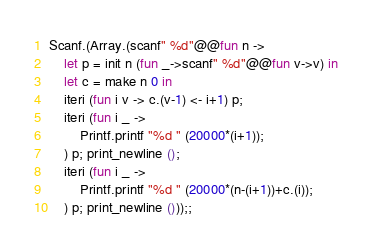Convert code to text. <code><loc_0><loc_0><loc_500><loc_500><_OCaml_>Scanf.(Array.(scanf" %d"@@fun n ->
	let p = init n (fun _->scanf" %d"@@fun v->v) in
	let c = make n 0 in
	iteri (fun i v -> c.(v-1) <- i+1) p;
	iteri (fun i _ -> 
		Printf.printf "%d " (20000*(i+1));
	) p; print_newline ();
	iteri (fun i _ -> 
		Printf.printf "%d " (20000*(n-(i+1))+c.(i));
	) p; print_newline ()));;</code> 